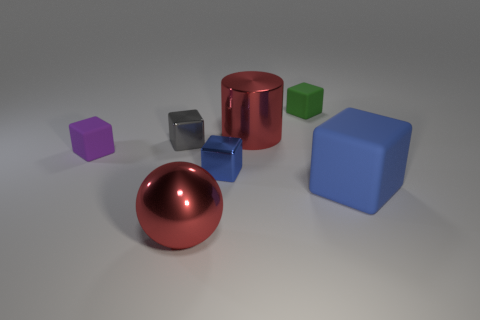Subtract 2 cubes. How many cubes are left? 3 Subtract all yellow cylinders. Subtract all green spheres. How many cylinders are left? 1 Add 2 large red rubber balls. How many objects exist? 9 Subtract all balls. How many objects are left? 6 Subtract all small green matte blocks. Subtract all small purple things. How many objects are left? 5 Add 3 small blue blocks. How many small blue blocks are left? 4 Add 3 large blue cubes. How many large blue cubes exist? 4 Subtract 0 purple spheres. How many objects are left? 7 